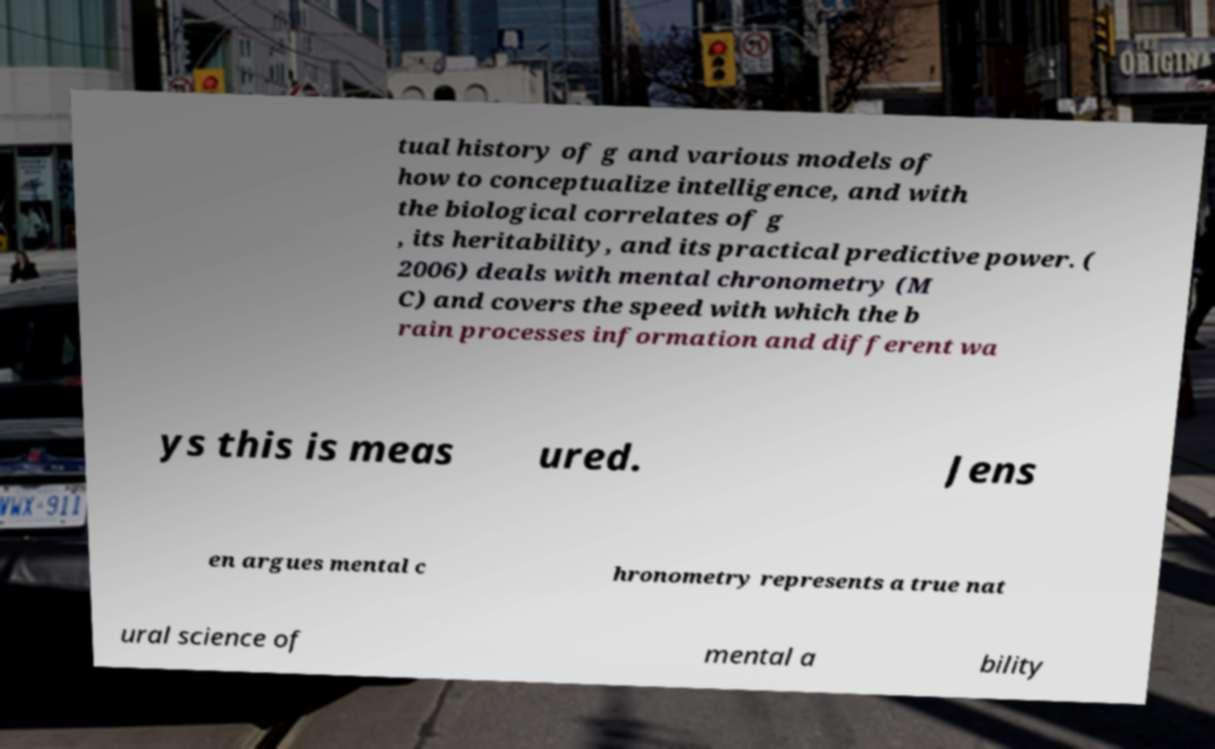There's text embedded in this image that I need extracted. Can you transcribe it verbatim? tual history of g and various models of how to conceptualize intelligence, and with the biological correlates of g , its heritability, and its practical predictive power. ( 2006) deals with mental chronometry (M C) and covers the speed with which the b rain processes information and different wa ys this is meas ured. Jens en argues mental c hronometry represents a true nat ural science of mental a bility 